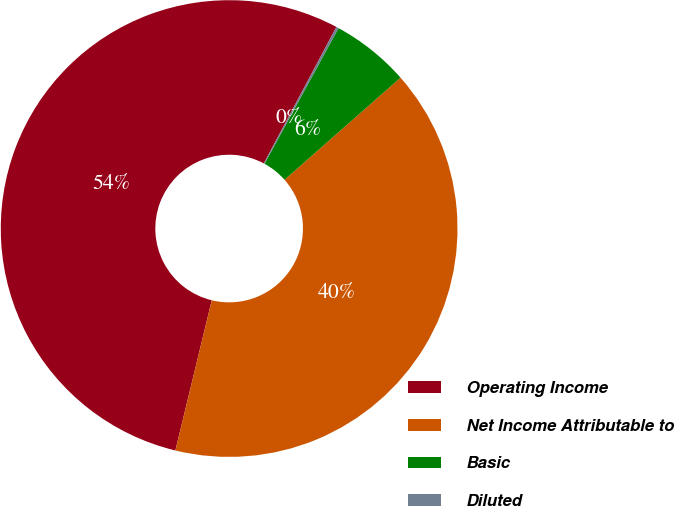Convert chart. <chart><loc_0><loc_0><loc_500><loc_500><pie_chart><fcel>Operating Income<fcel>Net Income Attributable to<fcel>Basic<fcel>Diluted<nl><fcel>54.0%<fcel>40.27%<fcel>5.56%<fcel>0.17%<nl></chart> 